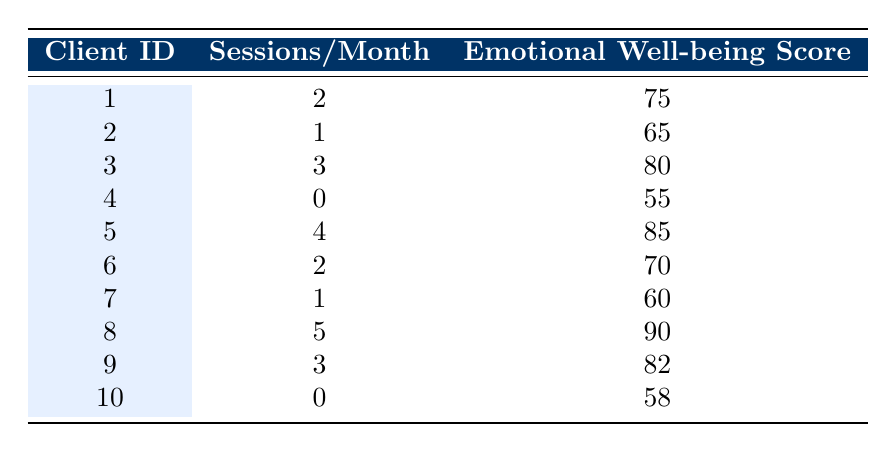How many clients had zero art therapy sessions? From the table, we can see that clients 4 and 10 both had zero sessions of art therapy listed under "Sessions/Month." Therefore, the total count of clients with zero sessions is 2.
Answer: 2 What is the emotional well-being score of the client who attended the maximum number of sessions? By scanning the "Sessions/Month" column, client 8 attended the most sessions, which is 5. Referring to the "Emotional Well-being Score" column, we see that client 8 has a score of 90.
Answer: 90 What is the average emotional well-being score for clients with at least two sessions per month? We identify the clients with at least two sessions: clients 1 (75), 3 (80), 5 (85), 6 (70), and 9 (82). The sum of their scores is (75 + 80 + 85 + 70 + 82) = 392, and there are 5 clients, so the average score is 392/5 = 78.4.
Answer: 78.4 Is there a client with a score of 65 or lower? We can look through the "Emotional Well-being Score" column, and we find that client 2 has a score of 65, which confirms that there is indeed a client with a score of 65 or lower.
Answer: Yes How does the emotional well-being score change with the number of sessions? By observing the data, we create a pattern: Clients with more sessions generally have higher scores. For instance, client 5 has 4 sessions and a score of 85; client 4 has 0 sessions and a score of 55. Thus, it appears there is a positive correlation between sessions and scores.
Answer: Higher sessions correspond to higher scores 